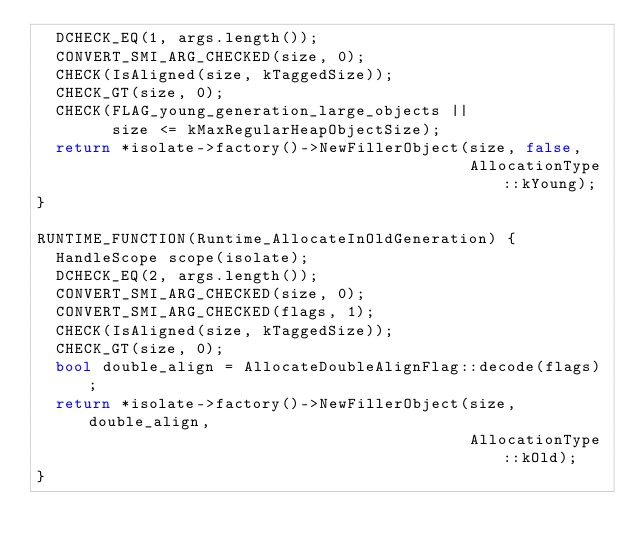Convert code to text. <code><loc_0><loc_0><loc_500><loc_500><_C++_>  DCHECK_EQ(1, args.length());
  CONVERT_SMI_ARG_CHECKED(size, 0);
  CHECK(IsAligned(size, kTaggedSize));
  CHECK_GT(size, 0);
  CHECK(FLAG_young_generation_large_objects ||
        size <= kMaxRegularHeapObjectSize);
  return *isolate->factory()->NewFillerObject(size, false,
                                              AllocationType::kYoung);
}

RUNTIME_FUNCTION(Runtime_AllocateInOldGeneration) {
  HandleScope scope(isolate);
  DCHECK_EQ(2, args.length());
  CONVERT_SMI_ARG_CHECKED(size, 0);
  CONVERT_SMI_ARG_CHECKED(flags, 1);
  CHECK(IsAligned(size, kTaggedSize));
  CHECK_GT(size, 0);
  bool double_align = AllocateDoubleAlignFlag::decode(flags);
  return *isolate->factory()->NewFillerObject(size, double_align,
                                              AllocationType::kOld);
}
</code> 